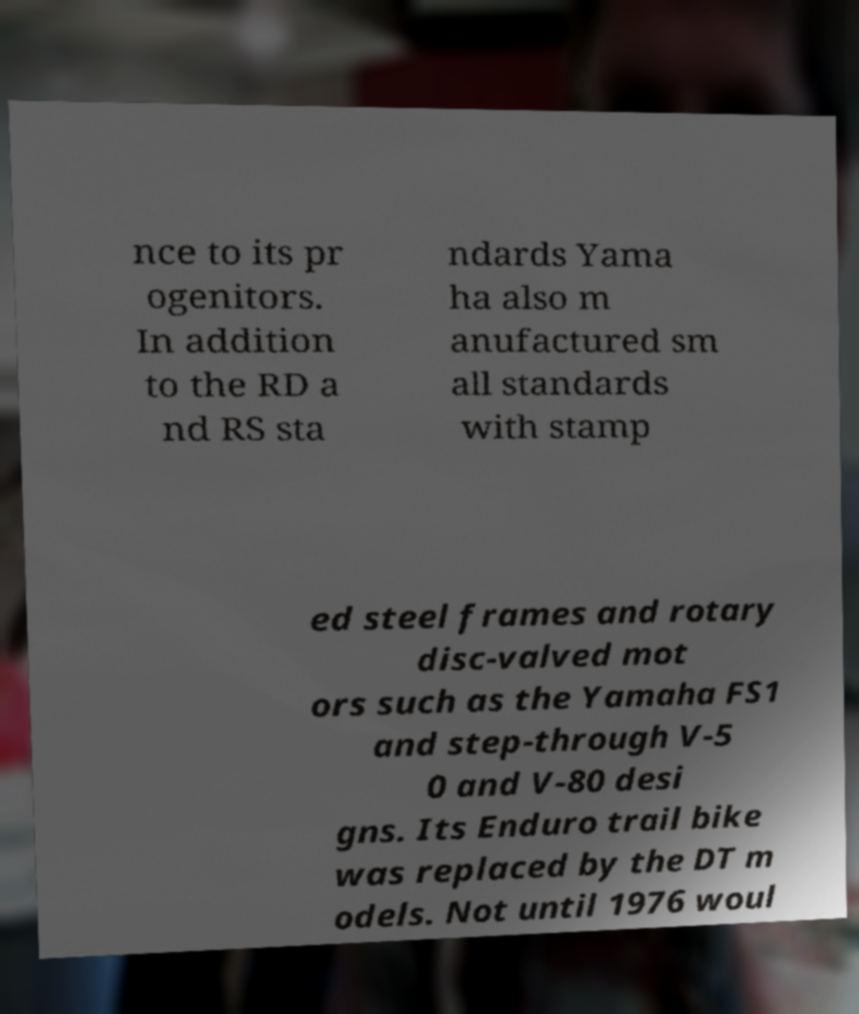What messages or text are displayed in this image? I need them in a readable, typed format. nce to its pr ogenitors. In addition to the RD a nd RS sta ndards Yama ha also m anufactured sm all standards with stamp ed steel frames and rotary disc-valved mot ors such as the Yamaha FS1 and step-through V-5 0 and V-80 desi gns. Its Enduro trail bike was replaced by the DT m odels. Not until 1976 woul 